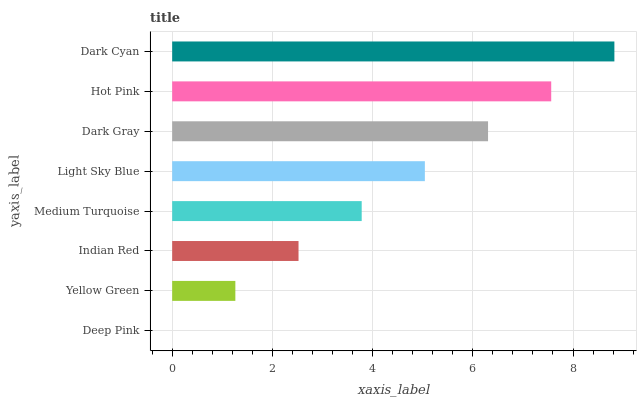Is Deep Pink the minimum?
Answer yes or no. Yes. Is Dark Cyan the maximum?
Answer yes or no. Yes. Is Yellow Green the minimum?
Answer yes or no. No. Is Yellow Green the maximum?
Answer yes or no. No. Is Yellow Green greater than Deep Pink?
Answer yes or no. Yes. Is Deep Pink less than Yellow Green?
Answer yes or no. Yes. Is Deep Pink greater than Yellow Green?
Answer yes or no. No. Is Yellow Green less than Deep Pink?
Answer yes or no. No. Is Light Sky Blue the high median?
Answer yes or no. Yes. Is Medium Turquoise the low median?
Answer yes or no. Yes. Is Hot Pink the high median?
Answer yes or no. No. Is Light Sky Blue the low median?
Answer yes or no. No. 